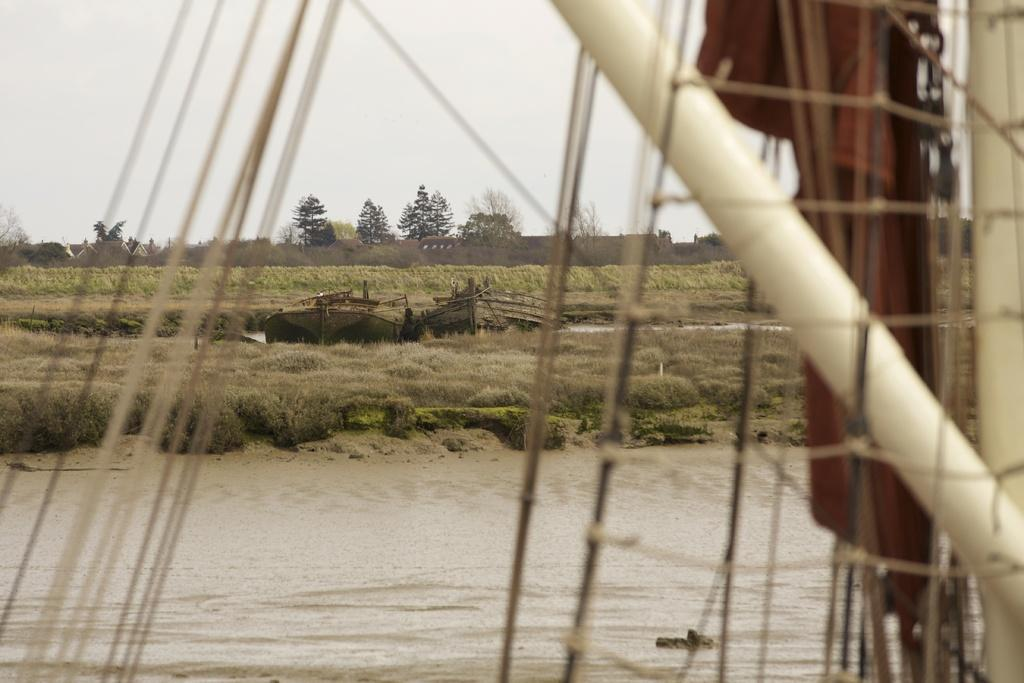What is the main feature of the image? The main feature of the image is water. What else can be seen in the image besides water? There are trees, boats, a cloudy sky, and plants on the ground in the image. Where is the receipt for the boat rental in the image? There is no receipt for a boat rental present in the image. What type of bubble can be seen floating in the water in the image? There are no bubbles present in the image. 